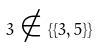Convert formula to latex. <formula><loc_0><loc_0><loc_500><loc_500>3 \notin \{ \{ 3 , 5 \} \}</formula> 